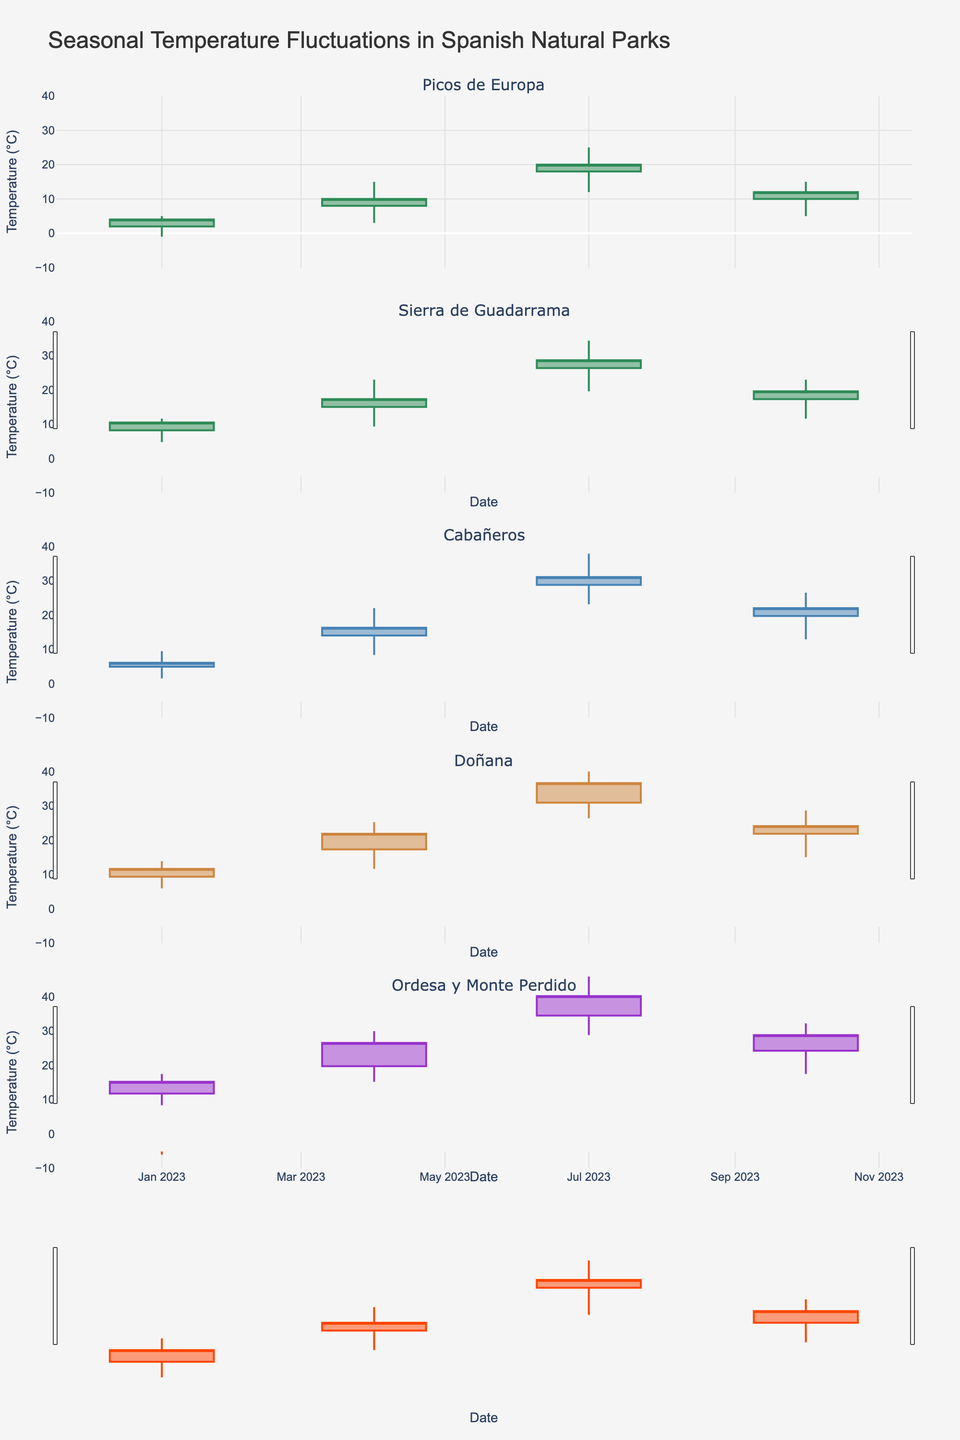Which natural park has the highest recorded temperature? The park with the highest recorded temperature can be found by looking at the highest value on the y-axis for the candlesticks. Doñana has the highest recorded temperature of 35°C in July.
Answer: Doñana What was the temperature range in Cabañeros in October? The temperature range can be determined by subtracting the lowest temperature (8°C) from the highest temperature (20°C) shown in the candlestick corresponding to October for Cabañeros. 20 - 8 = 12.
Answer: 12°C Comparing Picos de Europa and Sierra de Guadarrama, which park had a higher temperature in January? By comparing the candlesticks for January, Picos de Europa has a higher range (from -1°C to 5°C) compared to Sierra de Guadarrama (from -4°C to 3°C). Therefore, Picos de Europa had a higher temperature in January.
Answer: Picos de Europa What is the average closing temperature in Doñana across all seasons? The closing temperatures in Doñana for each season are 8, 18, 30, and 20. Sum these up: 8 + 18 + 30 + 20 = 76. Then, divide by 4 (since there are four seasons). 76 / 4 = 19.
Answer: 19°C Which month and park combo had the greatest temperature fluctuation? Temperature fluctuation is determined by the difference between the high and low values. By examining all parks and months, Doñana in July had the highest fluctuation of 35 - 20 = 15°C.
Answer: Doñana in July How many parks had a lower closing temperature in October compared to their opening temperature? By examining the candlesticks for October, the parks with closing temperatures lower than their opening temperatures are Picos de Europa (10 to 12) and Cabañeros (14 to 16). Sierra de Guadarrama and Doñana both have closing temperatures equal to or higher than their opening temperatures. Therefore, the answer is none.
Answer: 0 Which park shows the smallest temperature fluctuation in January? The smallest fluctuation can be identified by the difference between the high and low values in the candlestick for January. Ordesa y Monte Perdido has the smallest fluctuation of 4 - (-6) = 10°C.
Answer: Ordesa y Monte Perdido In which season was the highest temperature recorded in Sierra de Guadarrama? By observing the high values across all seasons for Sierra de Guadarrama, the peak value is 28°C in July. Hence, July had the highest temperature.
Answer: Summer (July) What is the highest closing temperature recorded in any month across all parks? By scanning the candlestick plot for the highest closing value across all parks and months, the highest is found to be 30°C for Doñana in July.
Answer: 30°C 